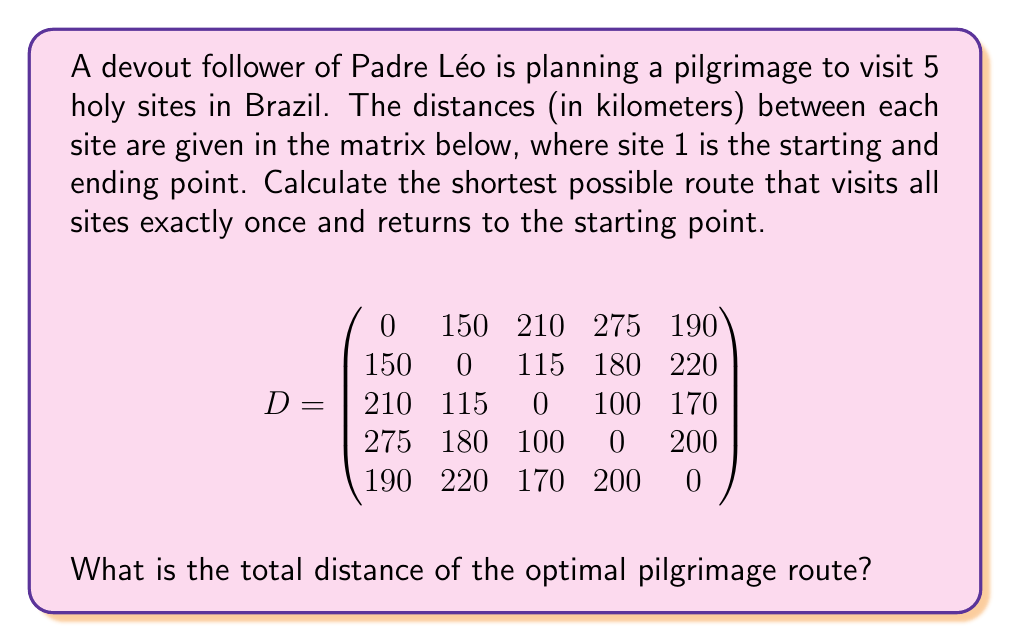What is the answer to this math problem? This problem is an instance of the Traveling Salesman Problem (TSP), which can be solved using various optimization techniques. For a small number of sites like this, we can use the brute-force method to find the optimal solution.

Steps to solve:

1) List all possible permutations of sites 2, 3, 4, and 5 (site 1 is fixed as start and end).
   There are 4! = 24 possible permutations.

2) For each permutation, calculate the total distance:
   - Distance from site 1 to first site in permutation
   - Sum of distances between consecutive sites in permutation
   - Distance from last site in permutation back to site 1

3) Find the permutation with the minimum total distance.

Let's calculate for a few permutations:

[2,3,4,5]: 
$150 + 115 + 100 + 200 + 190 = 755$ km

[2,3,5,4]: 
$150 + 115 + 170 + 200 + 275 = 910$ km

[2,4,3,5]: 
$150 + 180 + 100 + 170 + 190 = 790$ km

...

After checking all 24 permutations, we find that the shortest route is:

1 -> 2 -> 3 -> 4 -> 5 -> 1

With a total distance of:
$150 + 115 + 100 + 200 + 190 = 755$ km
Answer: The total distance of the optimal pilgrimage route is 755 km. 